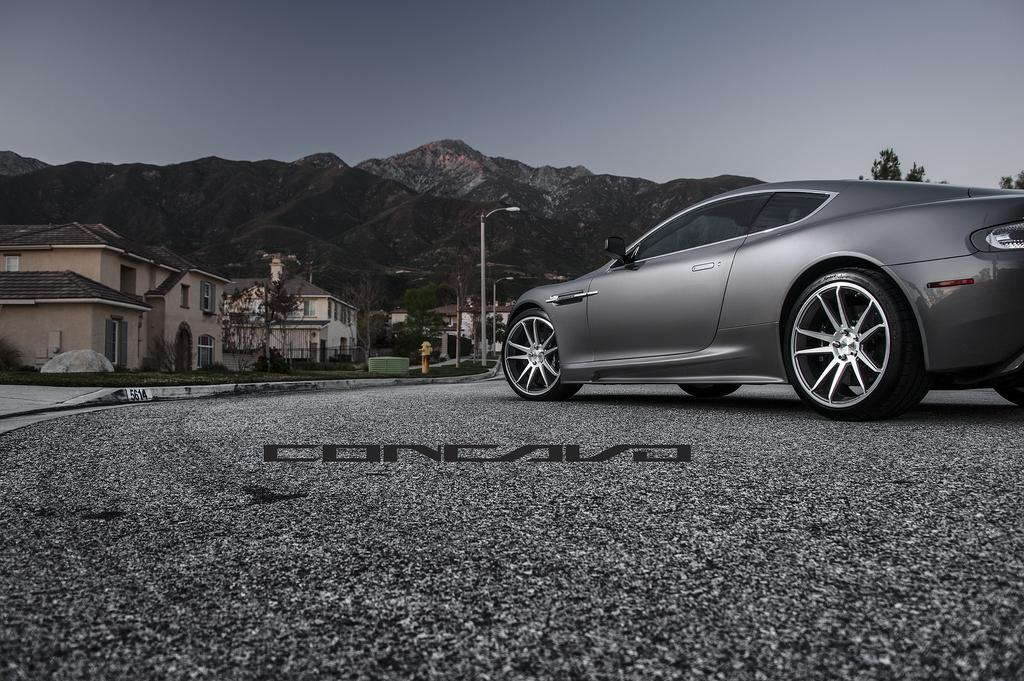What is the main subject of the image? There is a car on the road in the image. What can be seen in the background of the image? Buildings, trees, grass, other objects, street lights, poles, mountains, and the sky are visible in the background. How many eggs are being cooked on the car's hood in the image? There are no eggs present in the image, and they are not being cooked on the car's hood. 